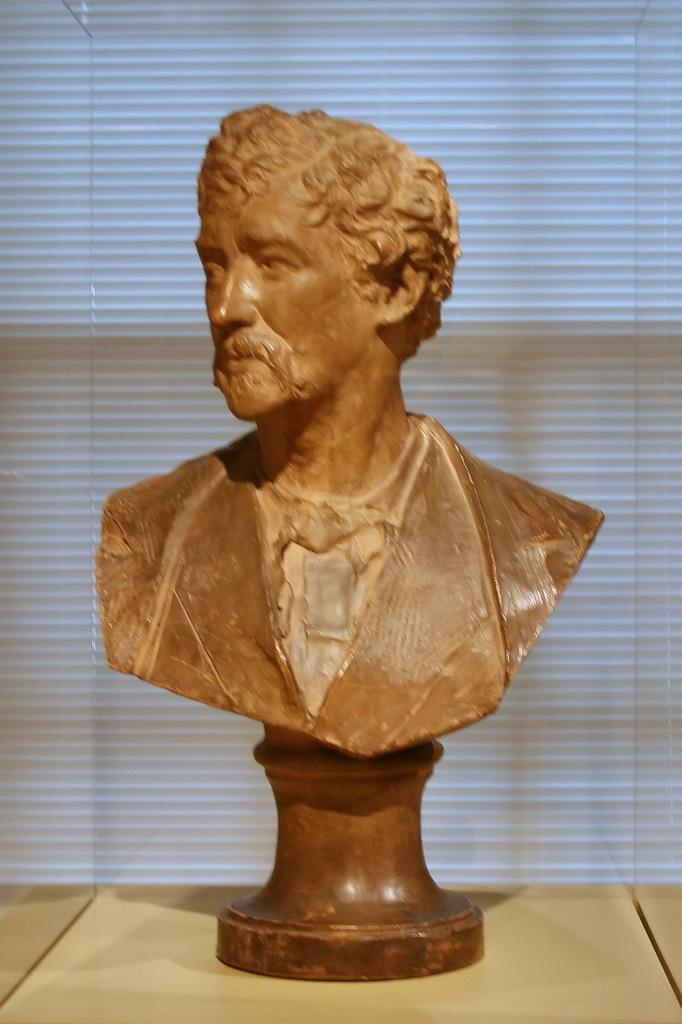What is the main subject of the image? There is a statue of a man in the image. How is the statue positioned in the image? The statue is on a stand. What is the stand placed on? The stand is on a platform. What is the platform enclosed in? The platform is placed in a glass box. Can you describe the object visible in the background of the image? Unfortunately, the provided facts do not mention any specific details about the object in the background. How many cattle are visible in the image? There are no cattle present in the image. What type of pancake is being served to the man in the image? There is no man or pancake present in the image; it features a statue of a man. 